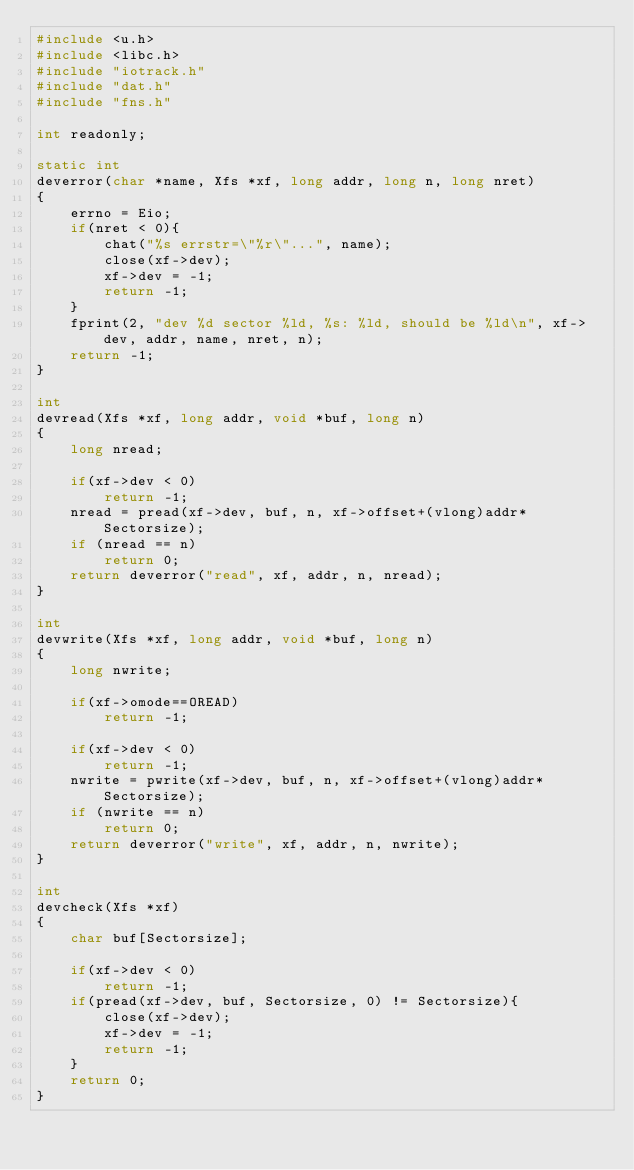Convert code to text. <code><loc_0><loc_0><loc_500><loc_500><_C_>#include <u.h>
#include <libc.h>
#include "iotrack.h"
#include "dat.h"
#include "fns.h"

int readonly;

static int
deverror(char *name, Xfs *xf, long addr, long n, long nret)
{
    errno = Eio;
    if(nret < 0){
        chat("%s errstr=\"%r\"...", name);
        close(xf->dev);
        xf->dev = -1;
        return -1;
    }
    fprint(2, "dev %d sector %ld, %s: %ld, should be %ld\n", xf->dev, addr, name, nret, n);
    return -1;
}

int
devread(Xfs *xf, long addr, void *buf, long n)
{
    long nread;

    if(xf->dev < 0)
        return -1;
    nread = pread(xf->dev, buf, n, xf->offset+(vlong)addr*Sectorsize);
    if (nread == n)
        return 0;
    return deverror("read", xf, addr, n, nread);
}

int
devwrite(Xfs *xf, long addr, void *buf, long n)
{
    long nwrite;

    if(xf->omode==OREAD)
        return -1;

    if(xf->dev < 0)
        return -1;
    nwrite = pwrite(xf->dev, buf, n, xf->offset+(vlong)addr*Sectorsize);
    if (nwrite == n)
        return 0;
    return deverror("write", xf, addr, n, nwrite);
}

int
devcheck(Xfs *xf)
{
    char buf[Sectorsize];

    if(xf->dev < 0)
        return -1;
    if(pread(xf->dev, buf, Sectorsize, 0) != Sectorsize){
        close(xf->dev);
        xf->dev = -1;
        return -1;
    }
    return 0;
}
</code> 